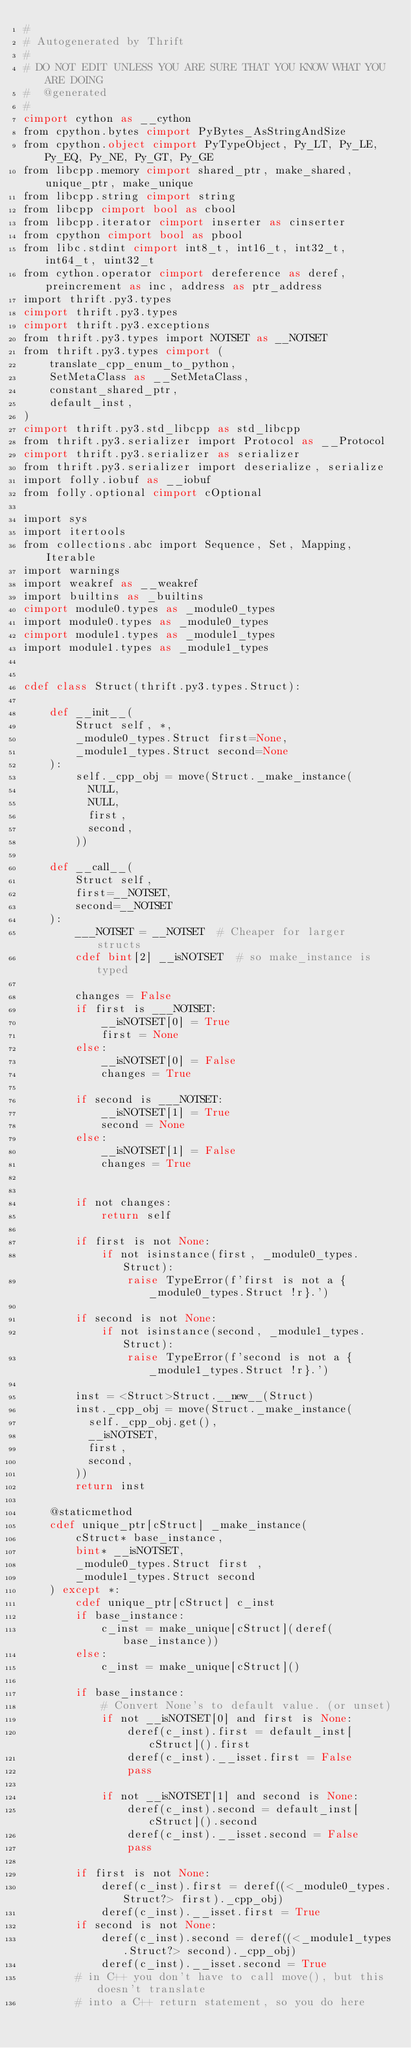Convert code to text. <code><loc_0><loc_0><loc_500><loc_500><_Cython_>#
# Autogenerated by Thrift
#
# DO NOT EDIT UNLESS YOU ARE SURE THAT YOU KNOW WHAT YOU ARE DOING
#  @generated
#
cimport cython as __cython
from cpython.bytes cimport PyBytes_AsStringAndSize
from cpython.object cimport PyTypeObject, Py_LT, Py_LE, Py_EQ, Py_NE, Py_GT, Py_GE
from libcpp.memory cimport shared_ptr, make_shared, unique_ptr, make_unique
from libcpp.string cimport string
from libcpp cimport bool as cbool
from libcpp.iterator cimport inserter as cinserter
from cpython cimport bool as pbool
from libc.stdint cimport int8_t, int16_t, int32_t, int64_t, uint32_t
from cython.operator cimport dereference as deref, preincrement as inc, address as ptr_address
import thrift.py3.types
cimport thrift.py3.types
cimport thrift.py3.exceptions
from thrift.py3.types import NOTSET as __NOTSET
from thrift.py3.types cimport (
    translate_cpp_enum_to_python,
    SetMetaClass as __SetMetaClass,
    constant_shared_ptr,
    default_inst,
)
cimport thrift.py3.std_libcpp as std_libcpp
from thrift.py3.serializer import Protocol as __Protocol
cimport thrift.py3.serializer as serializer
from thrift.py3.serializer import deserialize, serialize
import folly.iobuf as __iobuf
from folly.optional cimport cOptional

import sys
import itertools
from collections.abc import Sequence, Set, Mapping, Iterable
import warnings
import weakref as __weakref
import builtins as _builtins
cimport module0.types as _module0_types
import module0.types as _module0_types
cimport module1.types as _module1_types
import module1.types as _module1_types


cdef class Struct(thrift.py3.types.Struct):

    def __init__(
        Struct self, *,
        _module0_types.Struct first=None,
        _module1_types.Struct second=None
    ):
        self._cpp_obj = move(Struct._make_instance(
          NULL,
          NULL,
          first,
          second,
        ))

    def __call__(
        Struct self,
        first=__NOTSET,
        second=__NOTSET
    ):
        ___NOTSET = __NOTSET  # Cheaper for larger structs
        cdef bint[2] __isNOTSET  # so make_instance is typed

        changes = False
        if first is ___NOTSET:
            __isNOTSET[0] = True
            first = None
        else:
            __isNOTSET[0] = False
            changes = True

        if second is ___NOTSET:
            __isNOTSET[1] = True
            second = None
        else:
            __isNOTSET[1] = False
            changes = True


        if not changes:
            return self

        if first is not None:
            if not isinstance(first, _module0_types.Struct):
                raise TypeError(f'first is not a { _module0_types.Struct !r}.')

        if second is not None:
            if not isinstance(second, _module1_types.Struct):
                raise TypeError(f'second is not a { _module1_types.Struct !r}.')

        inst = <Struct>Struct.__new__(Struct)
        inst._cpp_obj = move(Struct._make_instance(
          self._cpp_obj.get(),
          __isNOTSET,
          first,
          second,
        ))
        return inst

    @staticmethod
    cdef unique_ptr[cStruct] _make_instance(
        cStruct* base_instance,
        bint* __isNOTSET,
        _module0_types.Struct first ,
        _module1_types.Struct second 
    ) except *:
        cdef unique_ptr[cStruct] c_inst
        if base_instance:
            c_inst = make_unique[cStruct](deref(base_instance))
        else:
            c_inst = make_unique[cStruct]()

        if base_instance:
            # Convert None's to default value. (or unset)
            if not __isNOTSET[0] and first is None:
                deref(c_inst).first = default_inst[cStruct]().first
                deref(c_inst).__isset.first = False
                pass

            if not __isNOTSET[1] and second is None:
                deref(c_inst).second = default_inst[cStruct]().second
                deref(c_inst).__isset.second = False
                pass

        if first is not None:
            deref(c_inst).first = deref((<_module0_types.Struct?> first)._cpp_obj)
            deref(c_inst).__isset.first = True
        if second is not None:
            deref(c_inst).second = deref((<_module1_types.Struct?> second)._cpp_obj)
            deref(c_inst).__isset.second = True
        # in C++ you don't have to call move(), but this doesn't translate
        # into a C++ return statement, so you do here</code> 